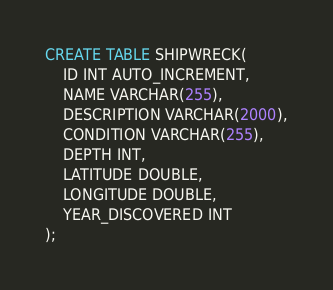<code> <loc_0><loc_0><loc_500><loc_500><_SQL_>CREATE TABLE SHIPWRECK(
    ID INT AUTO_INCREMENT,
    NAME VARCHAR(255),
    DESCRIPTION VARCHAR(2000),
    CONDITION VARCHAR(255),
    DEPTH INT,
    LATITUDE DOUBLE,
    LONGITUDE DOUBLE,
    YEAR_DISCOVERED INT
);</code> 